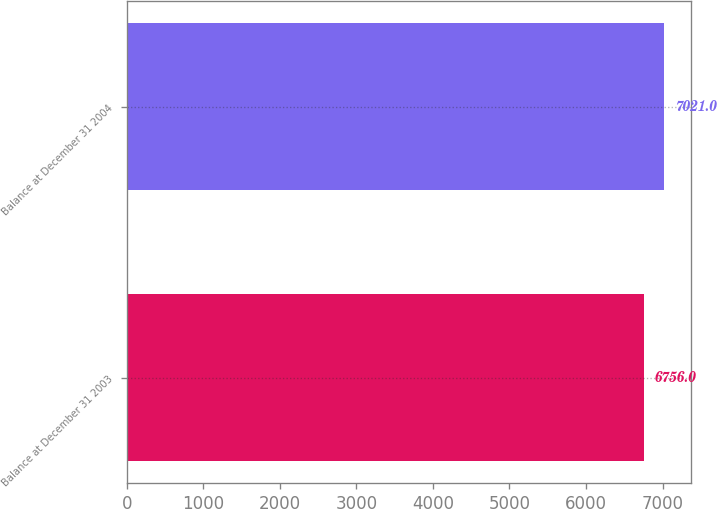Convert chart to OTSL. <chart><loc_0><loc_0><loc_500><loc_500><bar_chart><fcel>Balance at December 31 2003<fcel>Balance at December 31 2004<nl><fcel>6756<fcel>7021<nl></chart> 